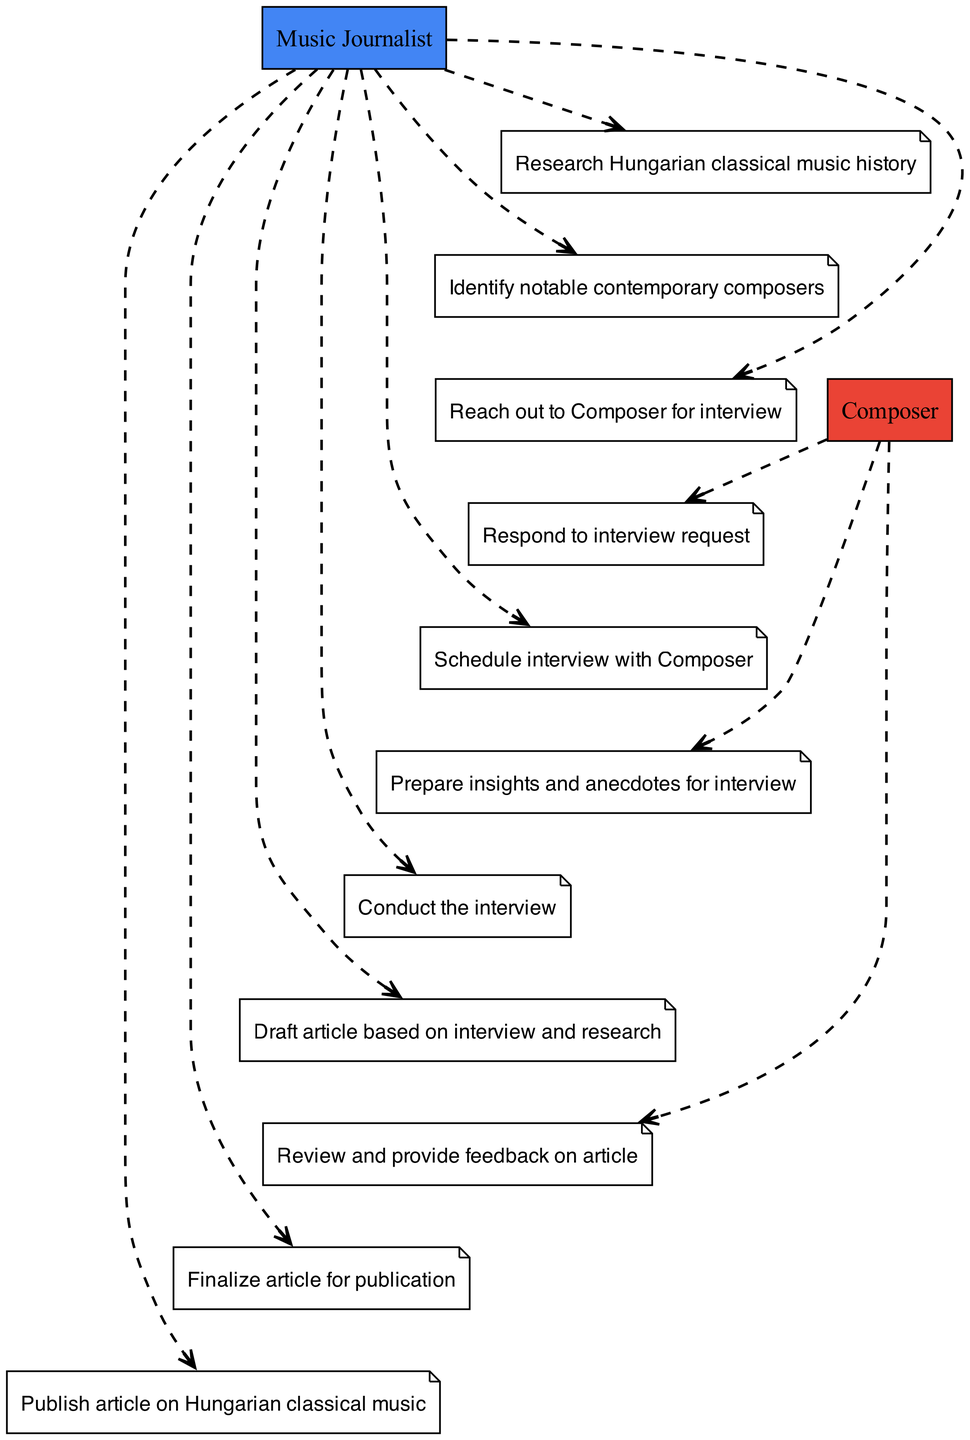What is the first action taken by the Music Journalist? The first action in the diagram by the Music Journalist is "Research Hungarian classical music history," indicating the starting point of the collaboration process.
Answer: Research Hungarian classical music history How many actions does the Composer take in the sequence? Counting the actions listed for the Composer, there are three actions: responding to the interview request, preparing insights and anecdotes for the interview, and reviewing and providing feedback on the article.
Answer: Three What is the last action in the sequence? The final action in the sequence is "Publish article on Hungarian classical music," which signifies the completion of the collaborative effort between the Music Journalist and the Composer.
Answer: Publish article on Hungarian classical music Which actor prepares insights for the interview? The diagram indicates that it is the Composer who prepares insights and anecdotes for the interview, reflecting their contribution to the discussion.
Answer: Composer How does the Music Journalist finalize the article? The Music Journalist finalizes the article for publication after receiving feedback from the Composer, showing a collaborative aspect in refining the content for release.
Answer: Finalize article for publication What action follows the scheduling of the interview? After the Music Journalist schedules the interview, the Composer prepares insights and anecdotes for the interview, indicating a sequence of preparation leading to the interview itself.
Answer: Prepare insights and anecdotes for interview What is the role of the Music Journalist after conducting the interview? After conducting the interview, the Music Journalist’s role is to draft the article based on the interview and research, showing a progression from gathering information to creating content.
Answer: Draft article based on interview and research Which action is linked to the Composer providing feedback? The action linked to the Composer providing feedback is "Review and provide feedback on article," which highlights the interactive nature of the collaboration between the two parties.
Answer: Review and provide feedback on article What actor is responsible for publishing the article? The actor responsible for publishing the article is the Music Journalist, which is the concluding action representing the culmination of their collaborative process.
Answer: Music Journalist 